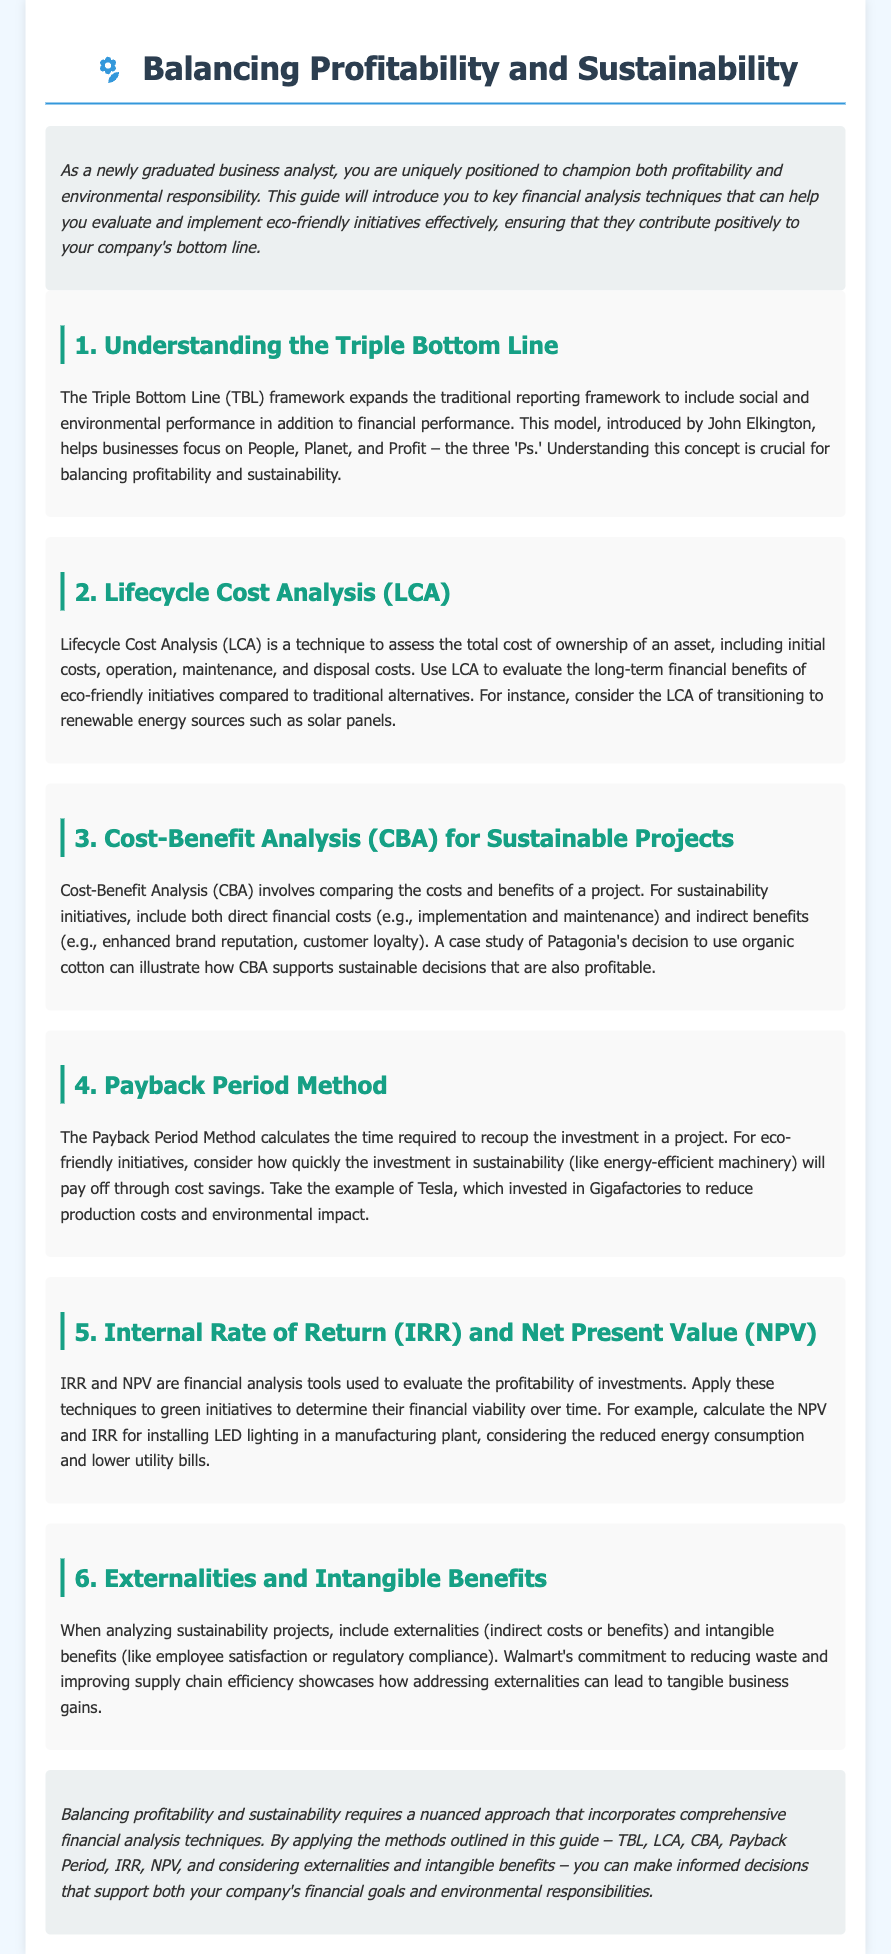what is the title of the document? The title is displayed prominently at the top of the document, labeled as "Balancing Profitability and Sustainability Guide."
Answer: Balancing Profitability and Sustainability Guide who introduced the Triple Bottom Line framework? The document mentions John Elkington as the individual who introduced the Triple Bottom Line framework.
Answer: John Elkington what technique assesses total cost of ownership? The document refers to Lifecycle Cost Analysis (LCA) as the technique for assessing total cost of ownership.
Answer: Lifecycle Cost Analysis (LCA) which analysis compares costs and benefits of a project? The Cost-Benefit Analysis (CBA) is the analysis method mentioned for comparing costs and benefits of a project in the sustainability context.
Answer: Cost-Benefit Analysis (CBA) what does the Payback Period Method calculate? The Payback Period Method calculates the time required to recoup the investment in a project.
Answer: time required to recoup the investment what are two financial analysis tools mentioned for evaluating investments? The document mentions Internal Rate of Return (IRR) and Net Present Value (NPV) as two financial analysis tools.
Answer: Internal Rate of Return (IRR) and Net Present Value (NPV) what is the purpose of including externalities in sustainability projects analysis? Including externalities helps address indirect costs or benefits associated with sustainability projects.
Answer: address indirect costs or benefits what does TBL stand for in financial analysis? TBL stands for Triple Bottom Line, which includes social and environmental performance along with financial performance.
Answer: Triple Bottom Line what company is used as an example for reducing waste? Walmart is mentioned as an example of a company committing to reducing waste and improving supply chain efficiency.
Answer: Walmart 